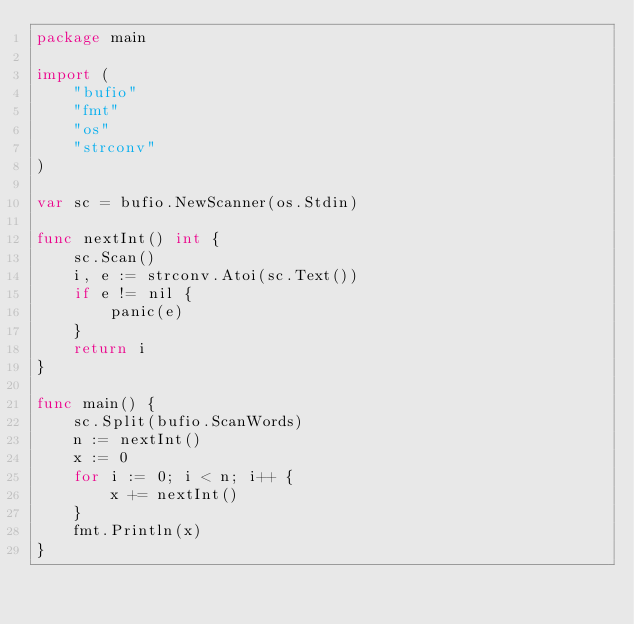<code> <loc_0><loc_0><loc_500><loc_500><_Go_>package main

import (
    "bufio"
    "fmt"
    "os"
    "strconv"
)

var sc = bufio.NewScanner(os.Stdin)

func nextInt() int {
    sc.Scan()
    i, e := strconv.Atoi(sc.Text())
    if e != nil {
        panic(e)
    }
    return i
}

func main() {
    sc.Split(bufio.ScanWords)
    n := nextInt()
    x := 0
    for i := 0; i < n; i++ {
        x += nextInt()
    }
    fmt.Println(x)
}</code> 